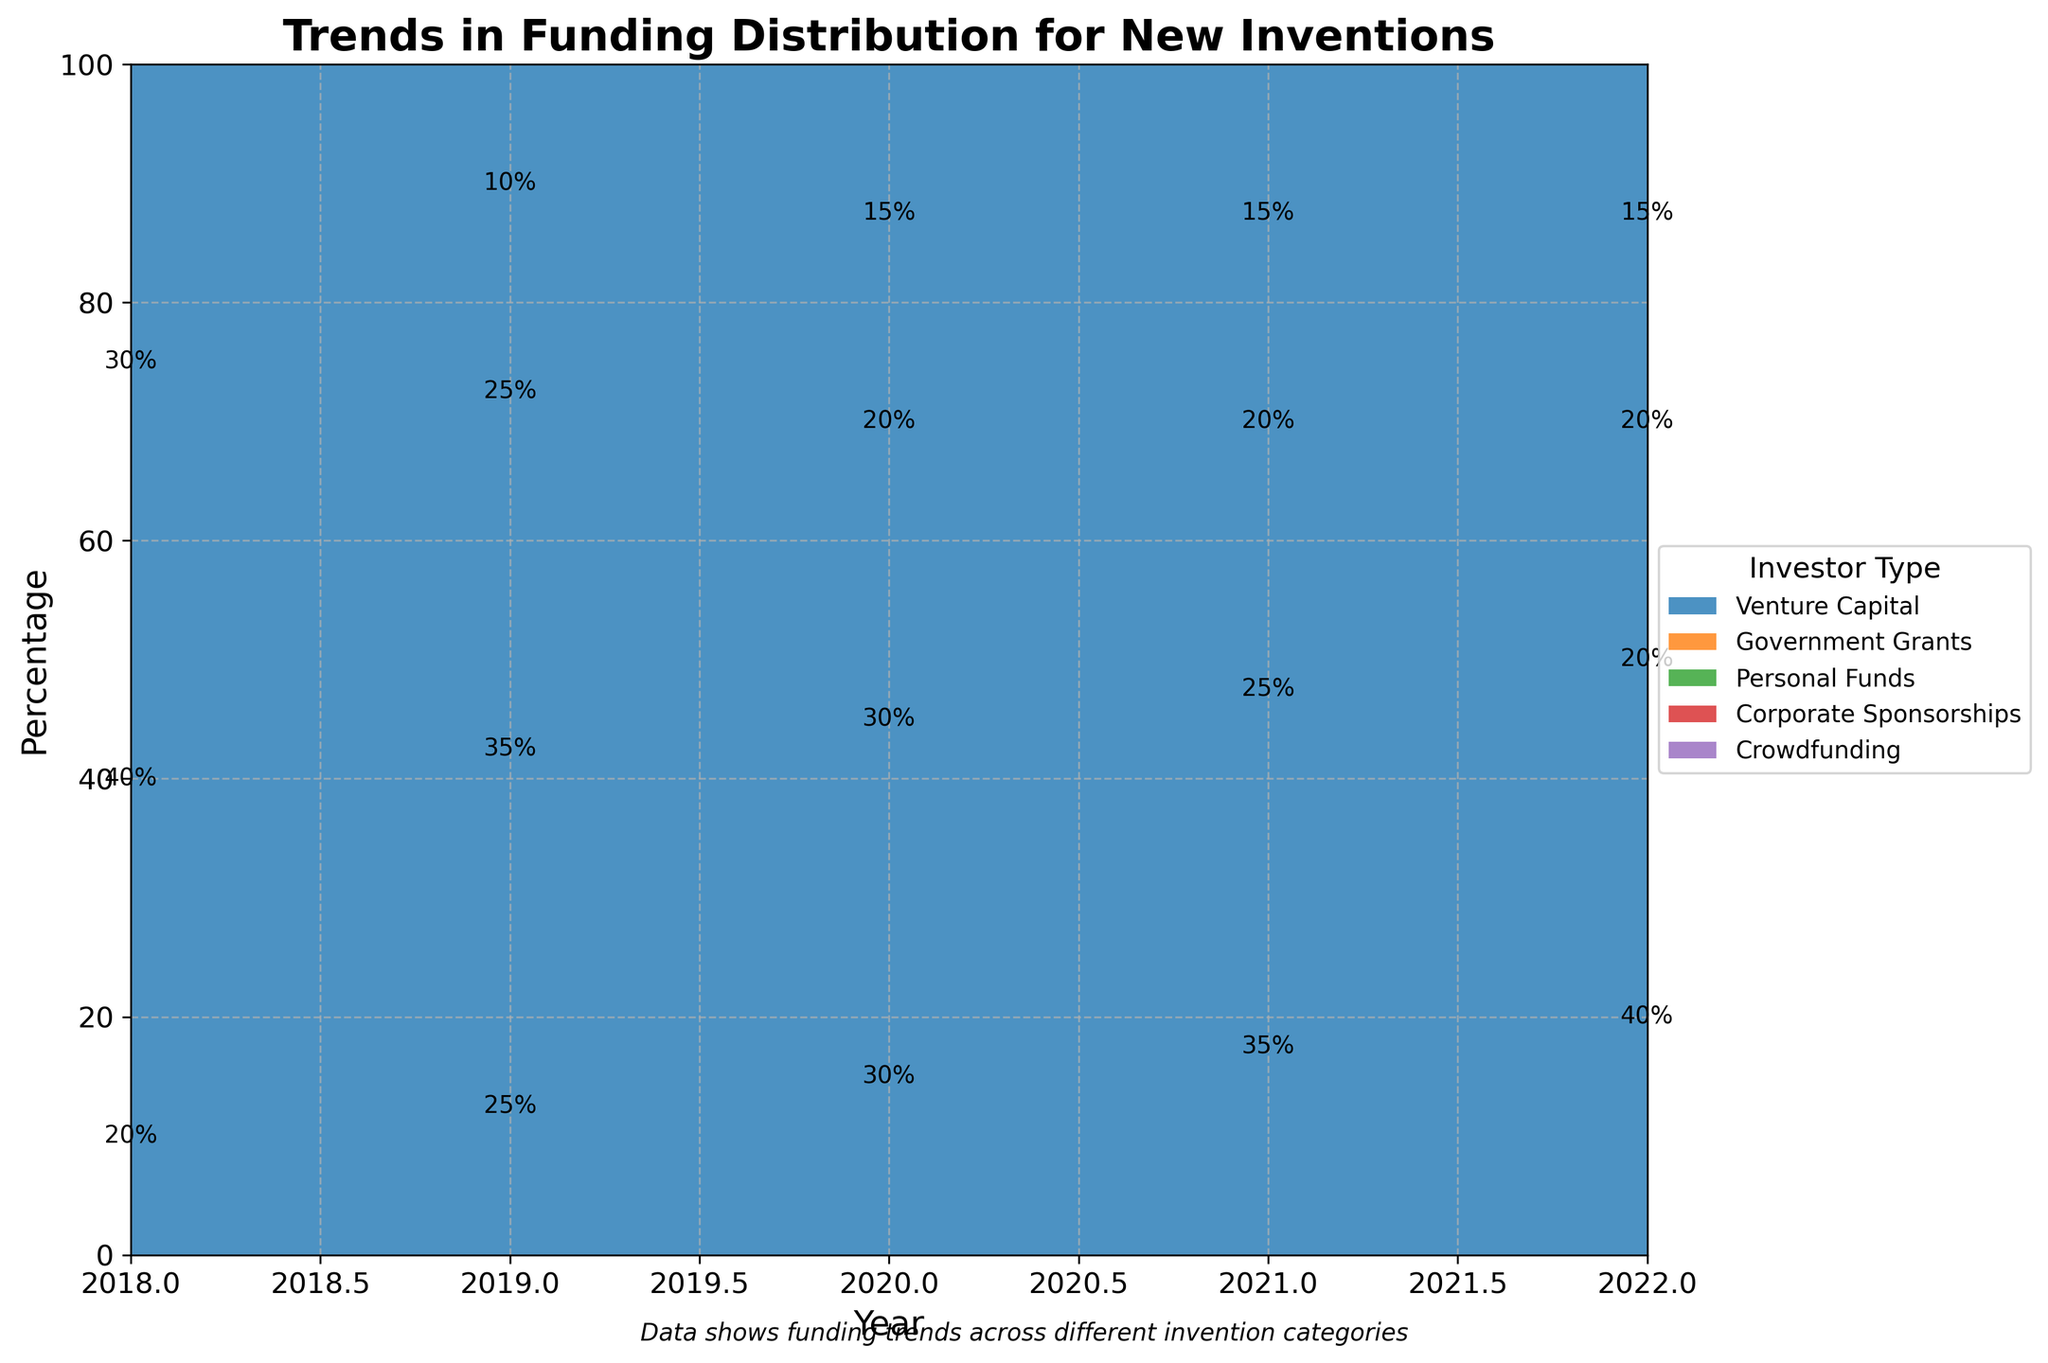What is the title of the chart? The title is displayed prominently at the top of the chart. It provides a brief summary of what the chart represents.
Answer: Trends in Funding Distribution for New Inventions Which type of investor had the most steady percentage across all years? By examining the trend lines for each investor type, compare the variations year by year. The investor type with the least fluctuation has the most steady percentage.
Answer: Crowdfunding How did the percentage of venture capital funding for consumer electronics change from 2018 to 2022? Identify the height of the venture capital section for consumer electronics in 2018 and 2022. The difference between these heights reflects the change.
Answer: Increased from 20% to 40% What is the overall trend for government grants in medical devices from 2018 to 2022? Track the government grants segment in the medical devices category each year, noting whether it is increasing or decreasing.
Answer: Decreasing trend Was there a year when corporate sponsorships had the same percentage across all categories? By checking each year's data for corporate sponsorships, see if all categories in a single year have the same percentage value.
Answer: No Which investor type had the highest funding percentage in medical devices in 2022? Look at the stacked area for medical devices in 2022 and identify which section is the tallest.
Answer: Venture Capital By how much did crowdfunding funding for industrial equipment change from 2018 to 2020? Compare the height of crowdfunding for industrial equipment in 2018 and 2020 by measuring the segment sizes. Subtract the value in 2018 from the value in 2020.
Answer: Increased from 2% to 3% Compare the distribution of personal funds and government grants for smart home solutions in 2018. Which was higher and by what percentage? Measure the heights of personal funds and government grants sections for smart home solutions in 2018. Subtract the smaller percentage from the larger one to find the difference.
Answer: Government Grants by 5% Which type of invention saw the largest increase in venture capital funding from 2018 to 2022? Compare the change in the venture capital percentage for each invention type between 2018 and 2022 and find the one with the largest increase.
Answer: Consumer Electronics How did the role of corporate sponsorships in funding smart home solutions change from 2019 to 2020? Look at the percentage of corporate sponsorships for smart home solutions in 2019 and 2020. Determine whether it increased, decreased, or remained the same.
Answer: Remained the same at 10% 